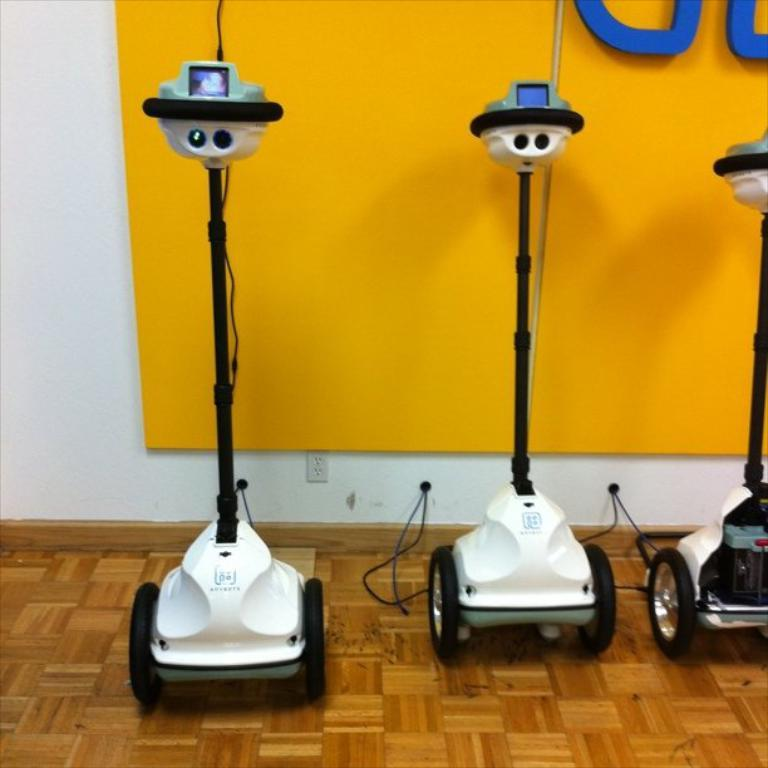What type of objects are present in the image? There are machines in the image. What colors are the machines? The machines are in white and black color. What can be seen in the background of the image? There is a wall in the background of the image. What colors are used on the wall? The wall is in yellow, white, and blue color. Can you tell me how many friends are sitting on the donkey in the image? There are no friends or donkeys present in the image; it features machines and a wall. What type of growth can be seen on the machines in the image? There is no growth visible on the machines in the image; they are stationary objects. 